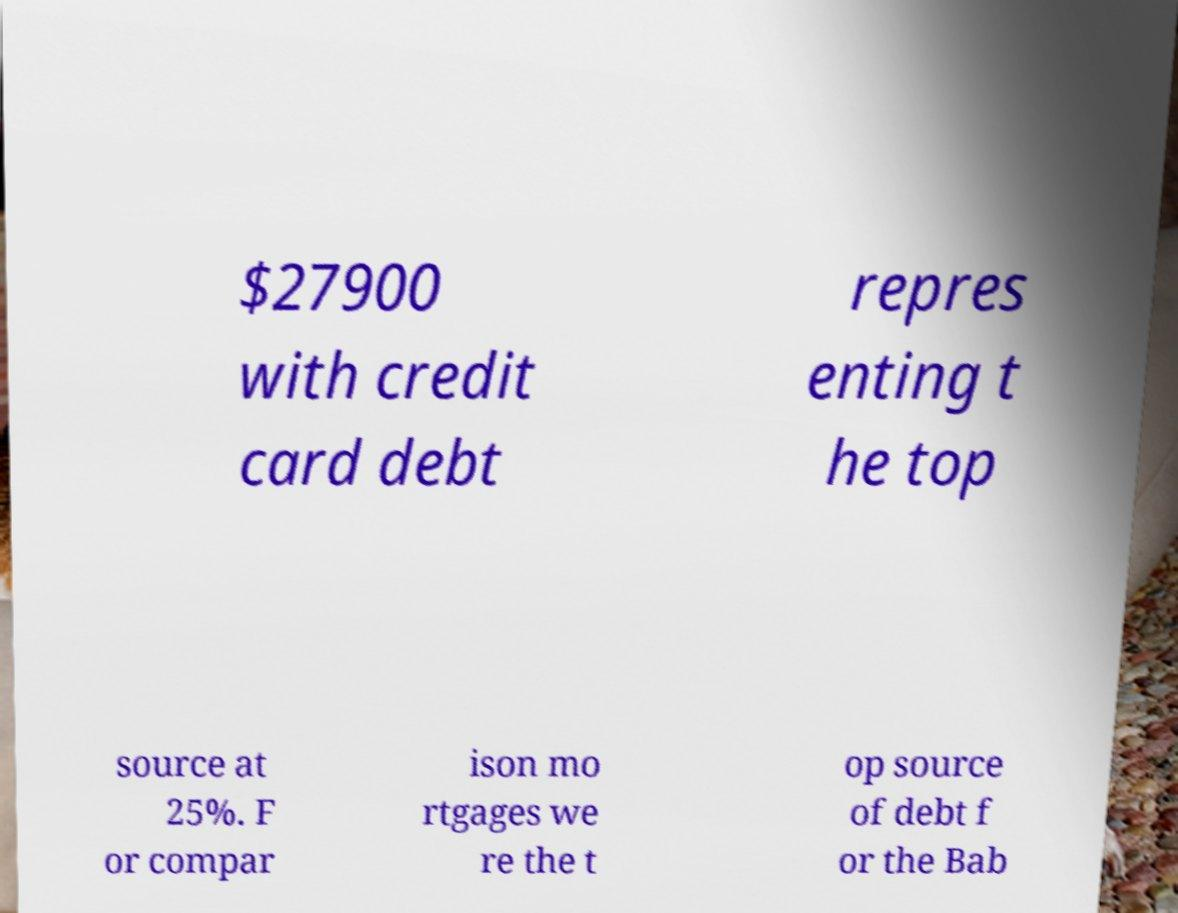Could you extract and type out the text from this image? $27900 with credit card debt repres enting t he top source at 25%. F or compar ison mo rtgages we re the t op source of debt f or the Bab 